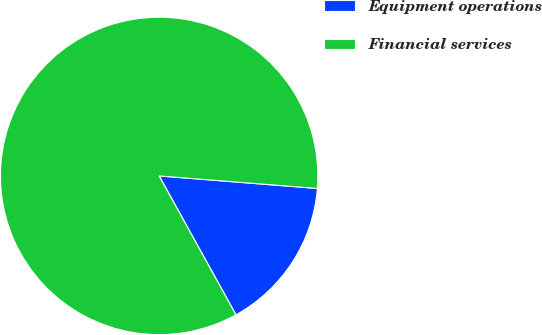<chart> <loc_0><loc_0><loc_500><loc_500><pie_chart><fcel>Equipment operations<fcel>Financial services<nl><fcel>15.7%<fcel>84.3%<nl></chart> 